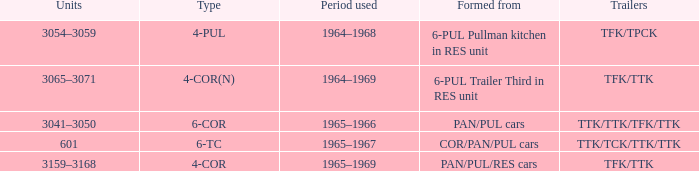Identify the shape that exhibits a 4-cornered structure. PAN/PUL/RES cars. 